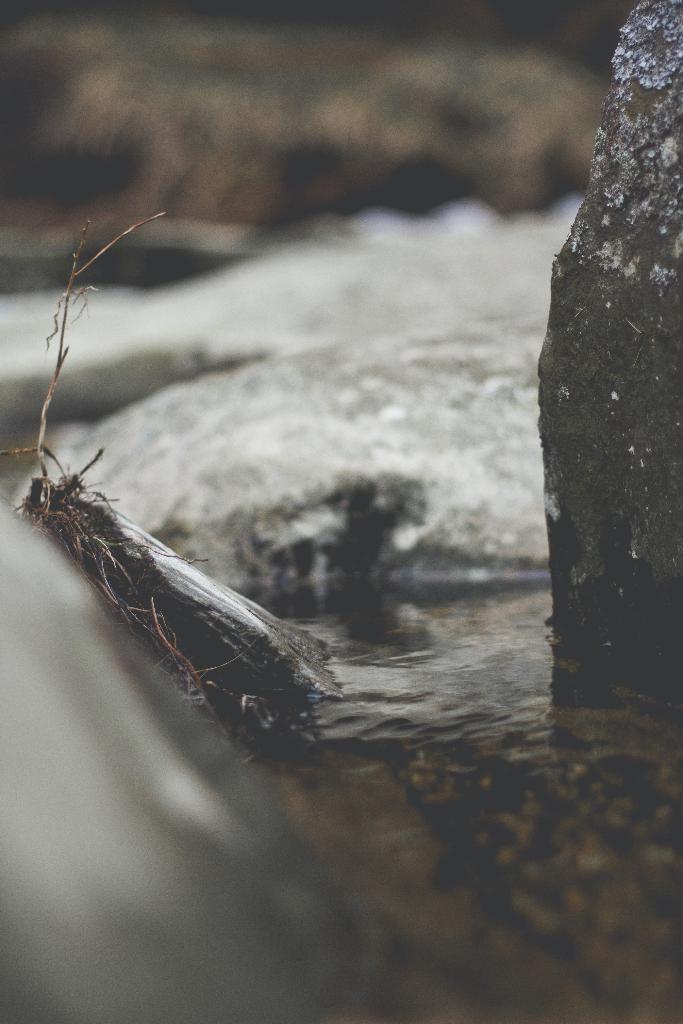Please provide a concise description of this image. In this image we can see the water and a rock. At the top the image is blurred. 